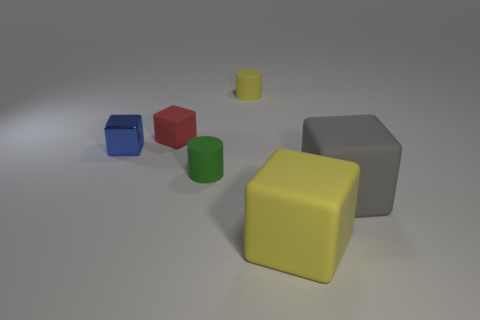Subtract 1 blocks. How many blocks are left? 3 Subtract all green cylinders. Subtract all gray blocks. How many cylinders are left? 1 Add 4 tiny objects. How many objects exist? 10 Subtract all cubes. How many objects are left? 2 Add 1 big gray objects. How many big gray objects exist? 2 Subtract 0 green spheres. How many objects are left? 6 Subtract all tiny gray metallic spheres. Subtract all green rubber cylinders. How many objects are left? 5 Add 5 metallic things. How many metallic things are left? 6 